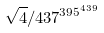<formula> <loc_0><loc_0><loc_500><loc_500>\sqrt { 4 } / 4 3 7 ^ { 3 9 5 ^ { 4 3 9 } }</formula> 